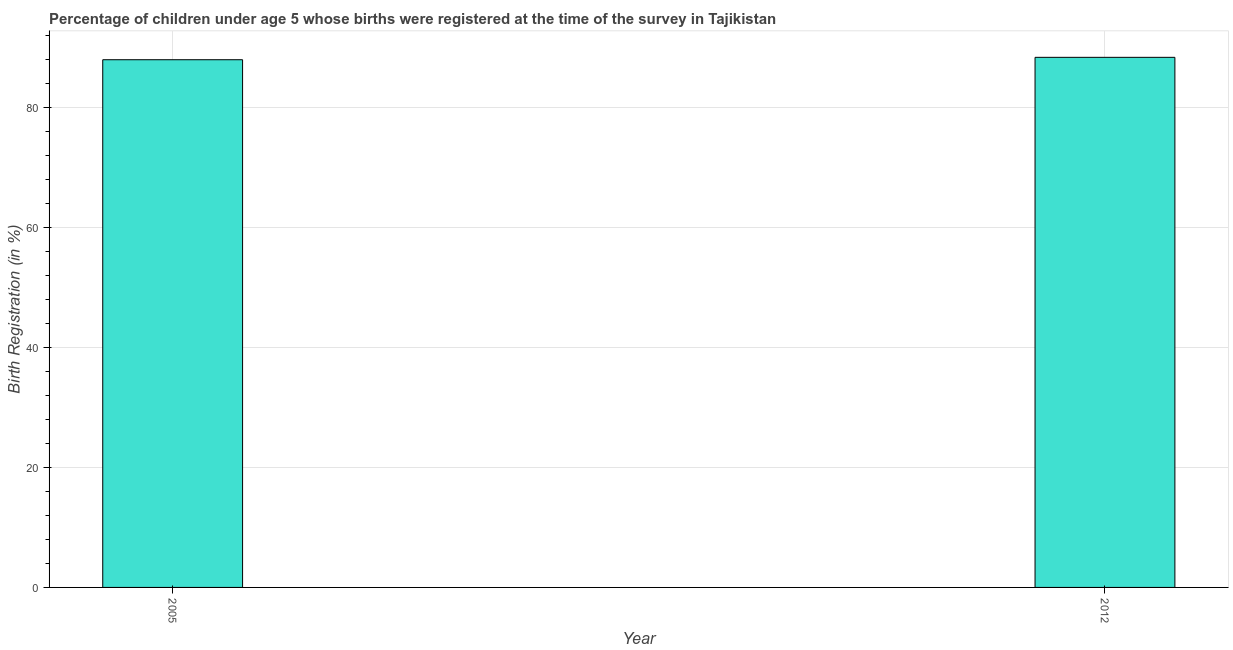What is the title of the graph?
Your answer should be compact. Percentage of children under age 5 whose births were registered at the time of the survey in Tajikistan. What is the label or title of the X-axis?
Your response must be concise. Year. What is the label or title of the Y-axis?
Give a very brief answer. Birth Registration (in %). What is the birth registration in 2012?
Provide a succinct answer. 88.4. Across all years, what is the maximum birth registration?
Provide a short and direct response. 88.4. In which year was the birth registration maximum?
Your answer should be compact. 2012. What is the sum of the birth registration?
Provide a short and direct response. 176.4. What is the average birth registration per year?
Keep it short and to the point. 88.2. What is the median birth registration?
Offer a terse response. 88.2. In how many years, is the birth registration greater than 12 %?
Offer a terse response. 2. Is the birth registration in 2005 less than that in 2012?
Provide a short and direct response. Yes. In how many years, is the birth registration greater than the average birth registration taken over all years?
Give a very brief answer. 1. How many bars are there?
Keep it short and to the point. 2. What is the Birth Registration (in %) of 2012?
Provide a succinct answer. 88.4. What is the difference between the Birth Registration (in %) in 2005 and 2012?
Provide a succinct answer. -0.4. 